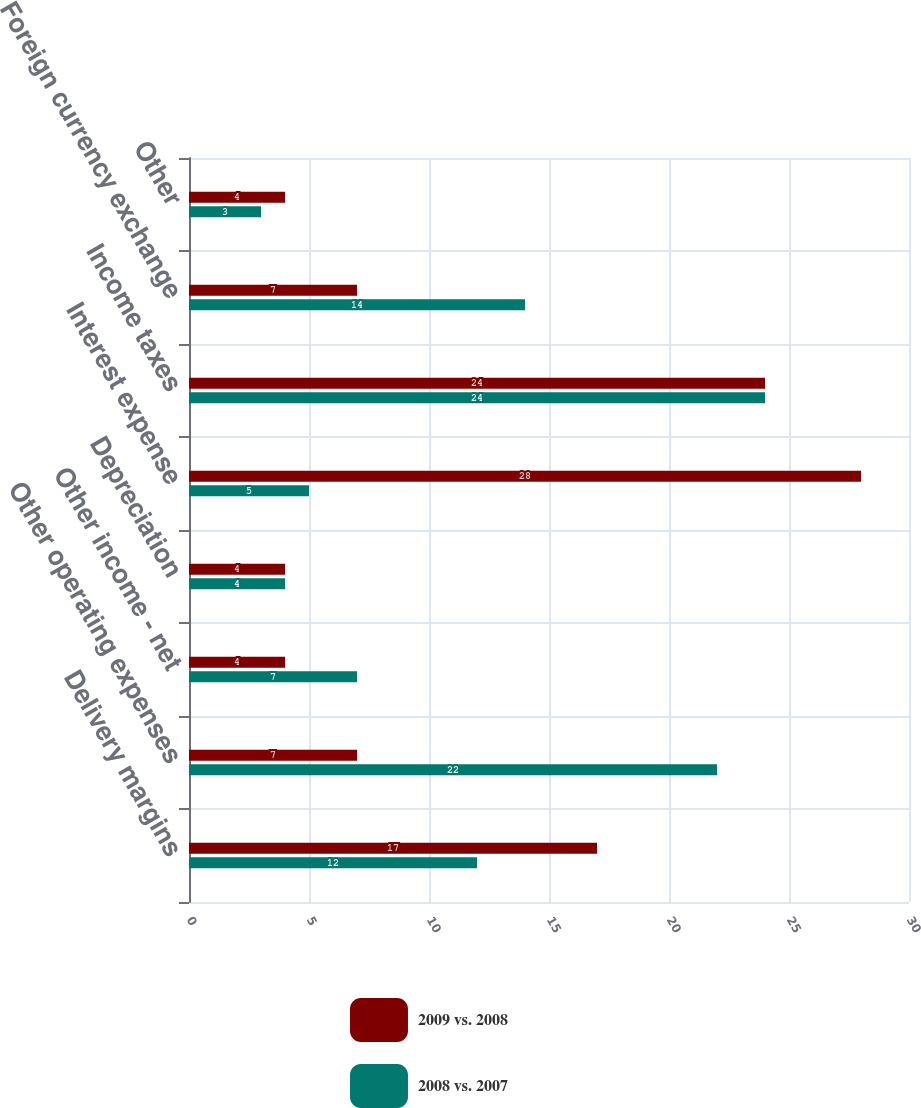<chart> <loc_0><loc_0><loc_500><loc_500><stacked_bar_chart><ecel><fcel>Delivery margins<fcel>Other operating expenses<fcel>Other income - net<fcel>Depreciation<fcel>Interest expense<fcel>Income taxes<fcel>Foreign currency exchange<fcel>Other<nl><fcel>2009 vs. 2008<fcel>17<fcel>7<fcel>4<fcel>4<fcel>28<fcel>24<fcel>7<fcel>4<nl><fcel>2008 vs. 2007<fcel>12<fcel>22<fcel>7<fcel>4<fcel>5<fcel>24<fcel>14<fcel>3<nl></chart> 